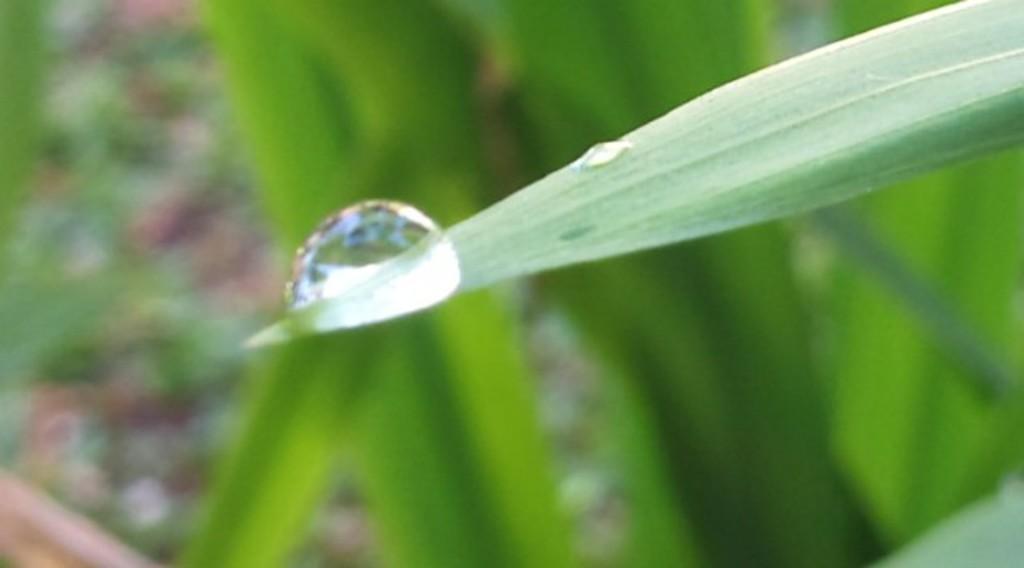Could you give a brief overview of what you see in this image? In this picture there is a water droplet in the center of the image on a leaf and there is greenery in the background area of the image. 